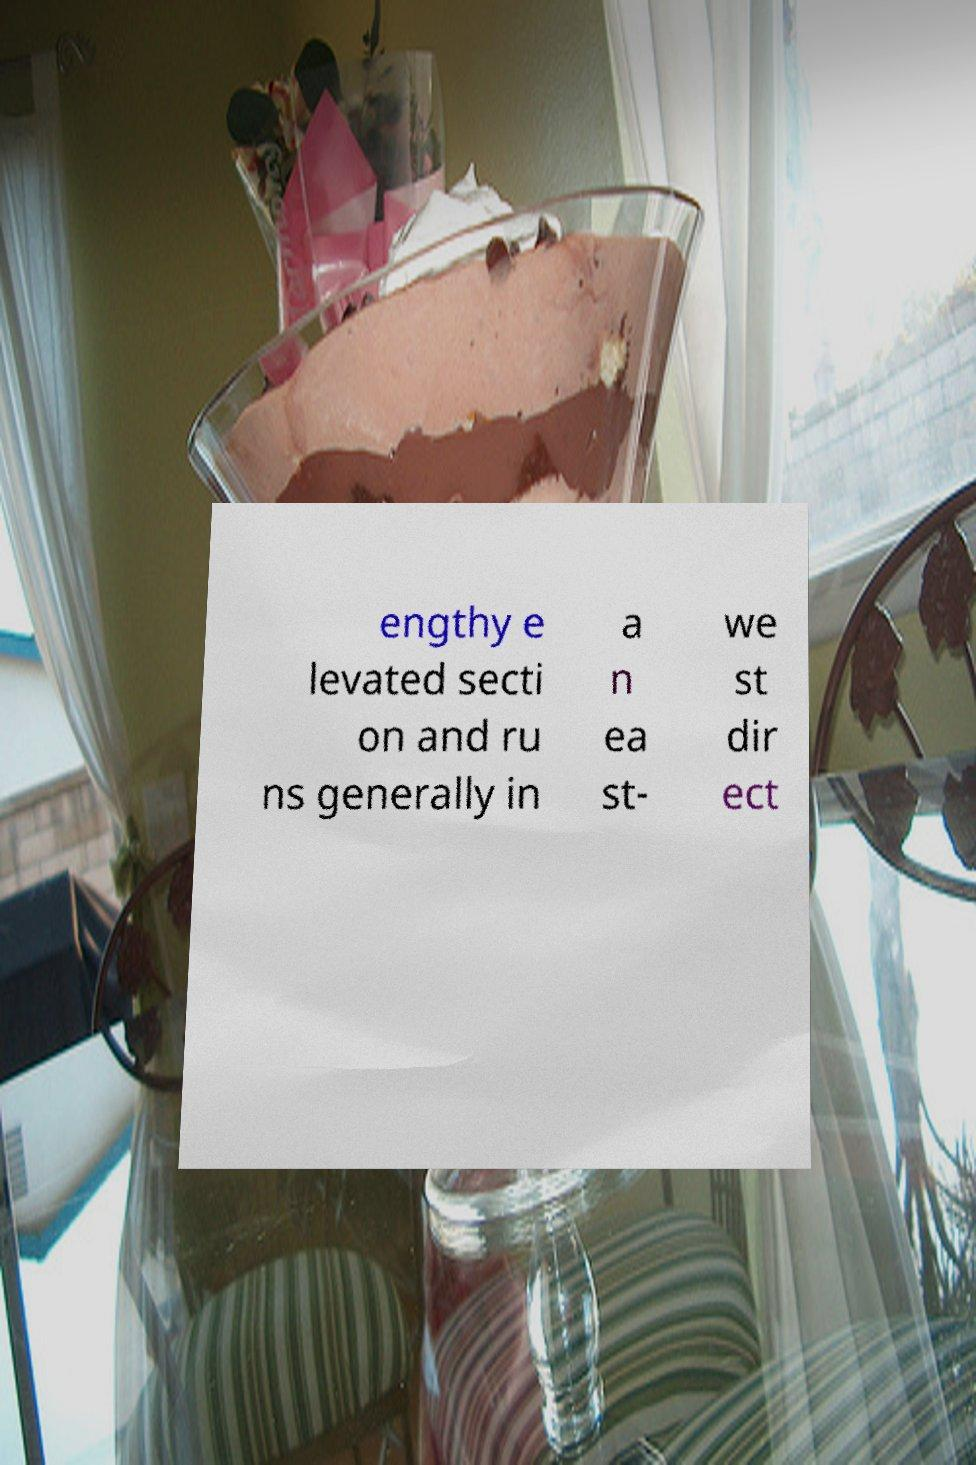Please read and relay the text visible in this image. What does it say? engthy e levated secti on and ru ns generally in a n ea st- we st dir ect 